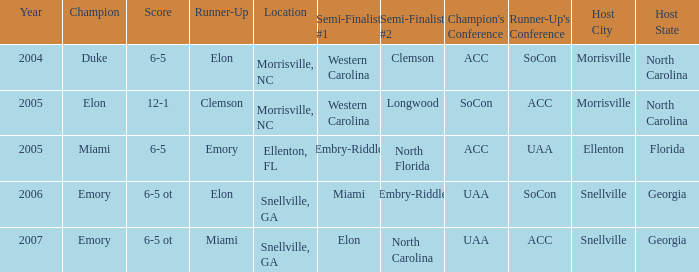Which team was the second semi finalist in 2007? North Carolina. Could you parse the entire table? {'header': ['Year', 'Champion', 'Score', 'Runner-Up', 'Location', 'Semi-Finalist #1', 'Semi-Finalist #2', "Champion's Conference", "Runner-Up's Conference", 'Host City', 'Host State'], 'rows': [['2004', 'Duke', '6-5', 'Elon', 'Morrisville, NC', 'Western Carolina', 'Clemson', 'ACC', 'SoCon', 'Morrisville', 'North Carolina'], ['2005', 'Elon', '12-1', 'Clemson', 'Morrisville, NC', 'Western Carolina', 'Longwood', 'SoCon', 'ACC', 'Morrisville', 'North Carolina'], ['2005', 'Miami', '6-5', 'Emory', 'Ellenton, FL', 'Embry-Riddle', 'North Florida', 'ACC', 'UAA', 'Ellenton', 'Florida'], ['2006', 'Emory', '6-5 ot', 'Elon', 'Snellville, GA', 'Miami', 'Embry-Riddle', 'UAA', 'SoCon', 'Snellville', 'Georgia'], ['2007', 'Emory', '6-5 ot', 'Miami', 'Snellville, GA', 'Elon', 'North Carolina', 'UAA', 'ACC', 'Snellville', 'Georgia']]} 